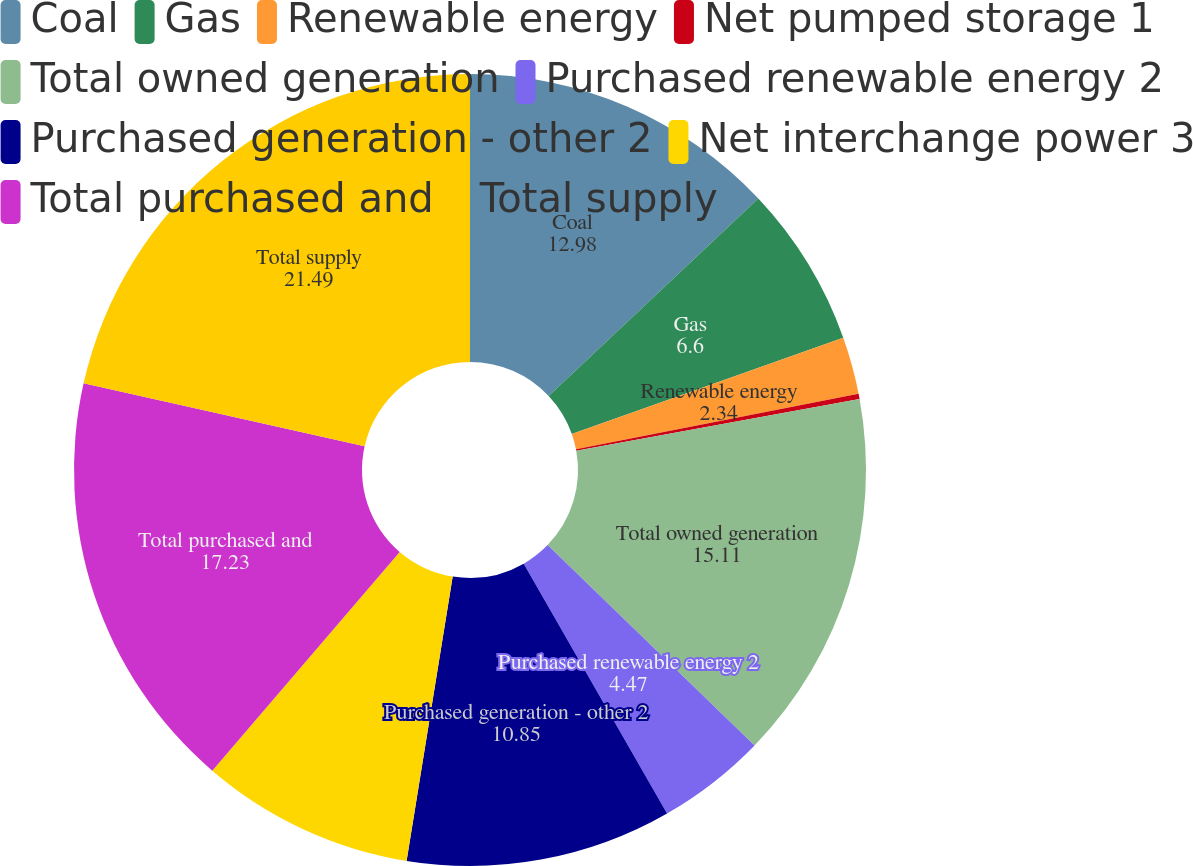Convert chart. <chart><loc_0><loc_0><loc_500><loc_500><pie_chart><fcel>Coal<fcel>Gas<fcel>Renewable energy<fcel>Net pumped storage 1<fcel>Total owned generation<fcel>Purchased renewable energy 2<fcel>Purchased generation - other 2<fcel>Net interchange power 3<fcel>Total purchased and<fcel>Total supply<nl><fcel>12.98%<fcel>6.6%<fcel>2.34%<fcel>0.21%<fcel>15.11%<fcel>4.47%<fcel>10.85%<fcel>8.72%<fcel>17.23%<fcel>21.49%<nl></chart> 